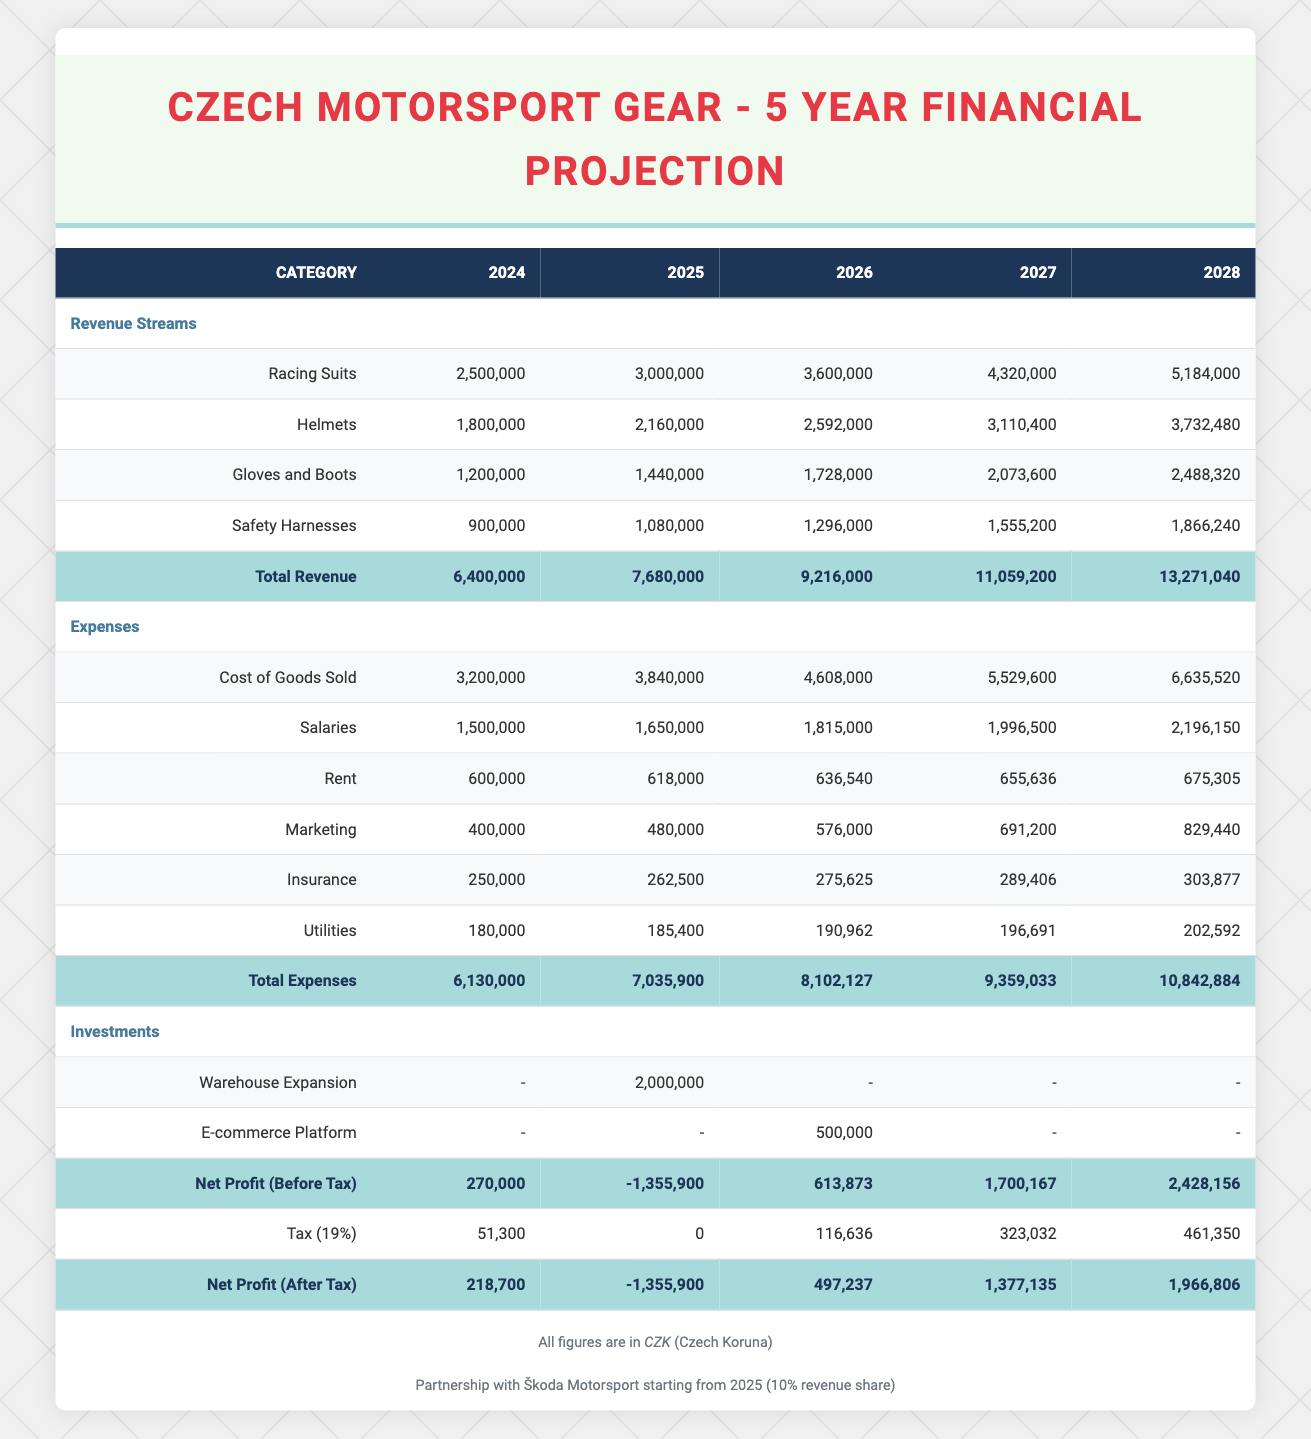What is the total revenue in 2026? The total revenue for 2026 is provided in the total row under the revenue section. It states that the total revenue is 9,216,000 CZK.
Answer: 9,216,000 CZK What is the annual growth rate of revenue from 2024 to 2025? The revenue in 2024 is 6,400,000 CZK, and in 2025 it is 7,680,000 CZK. To find the growth rate, we calculate: (7,680,000 - 6,400,000) / 6,400,000 = 0.20, or 20%.
Answer: 20% Is the cost of goods sold higher than total expenses in the year 2024? The cost of goods sold in 2024 is 3,200,000 CZK and total expenses are 6,130,000 CZK. Since 3,200,000 is less than 6,130,000, the statement is false.
Answer: No What is the net profit (after tax) for 2025? The net profit (after tax) for 2025 is shown in the net profit (after tax) row for that year, which is -1,355,900 CZK. This indicates a loss.
Answer: -1,355,900 CZK How much is spent on marketing in 2027 compared to 2026? The marketing expenses for 2027 are 691,200 CZK, and for 2026 they are 576,000 CZK. To find the difference: 691,200 - 576,000 = 115,200 CZK more is spent in 2027 than in 2026.
Answer: 115,200 CZK What is the average annual salary expense from 2024 to 2028? The annual salary expenses for each year from 2024 to 2028 are 1,500,000, 1,650,000, 1,815,000, 1,996,500, and 2,196,150. The total is 9,158,650 CZK, and divided by 5 years equals 1,831,730 CZK on average.
Answer: 1,831,730 CZK When does the partnership with Škoda Motorsport start? The partnership with Škoda Motorsport begins in 2025 according to the note in the projected financials.
Answer: 2025 Does the business show a profit after tax by 2028? The net profit (after tax) for 2028 is recorded as 1,966,806 CZK, which is positive, indicating the business does show a profit after tax by this year.
Answer: Yes 